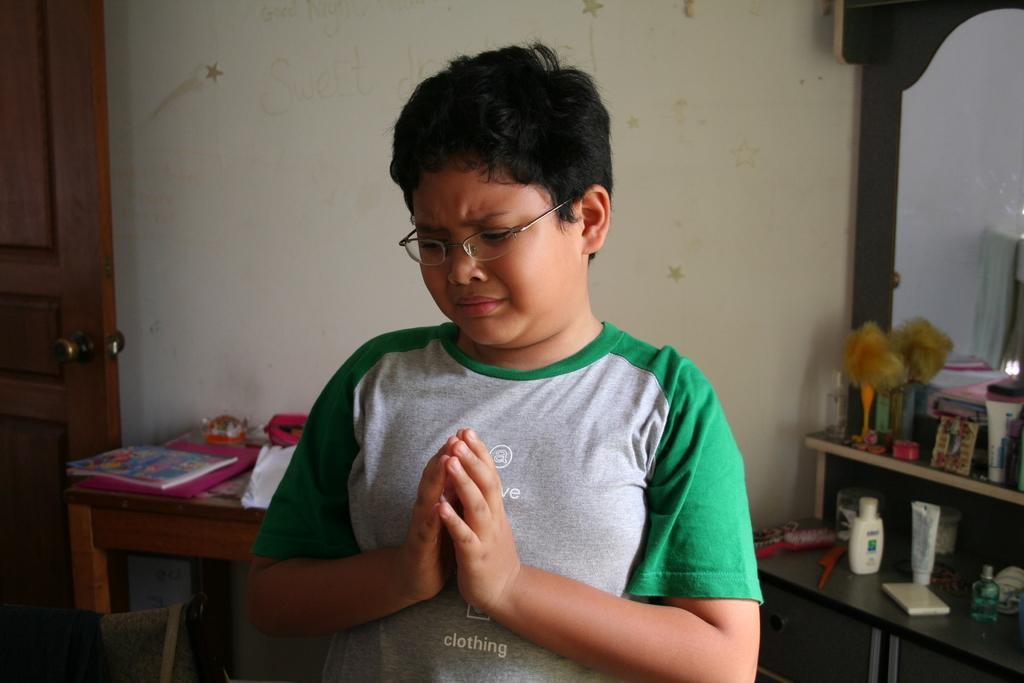How would you summarize this image in a sentence or two? This picture shows a boy crying and we see his hands together and we see a book on the table and we see a mirror on the right 